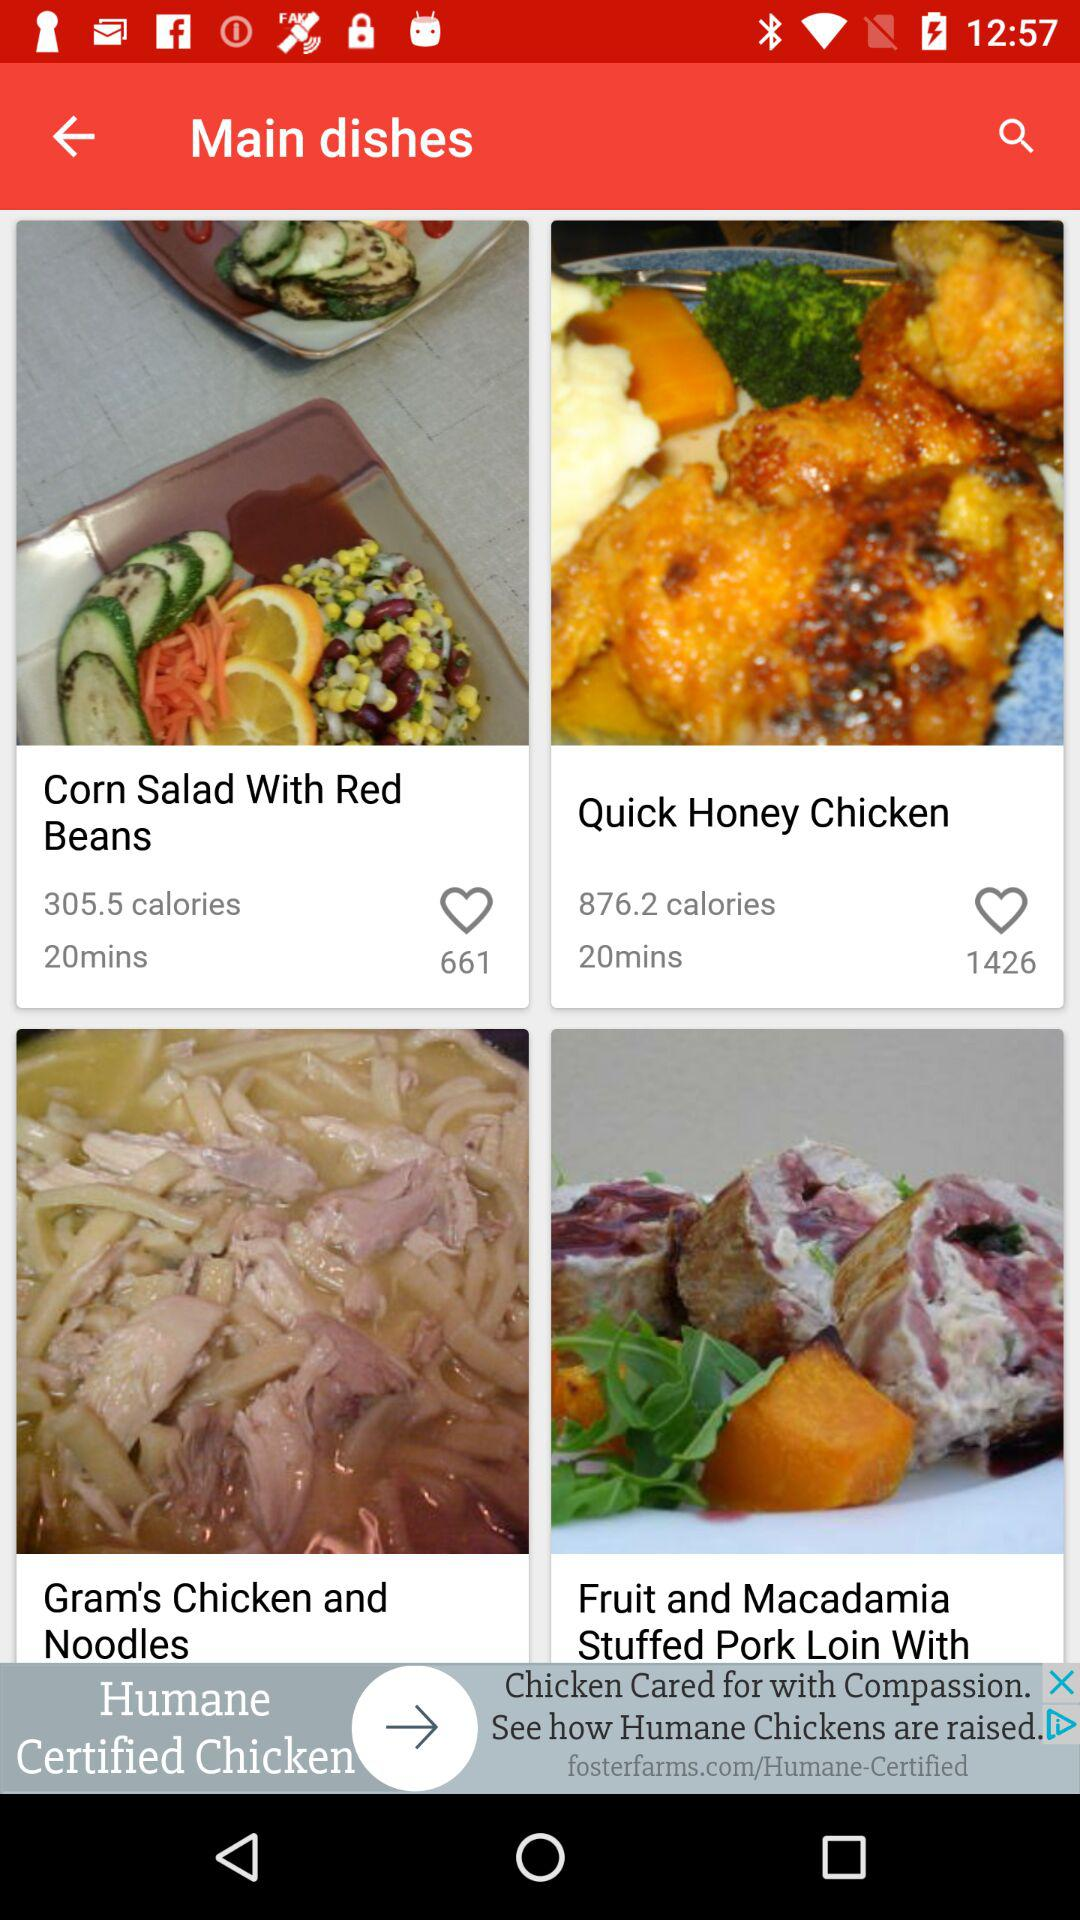What is the amount of the calories in "Corn Salad With Red Beans"? There are 305.5 calories in "Corn Salad With Red Beans". 